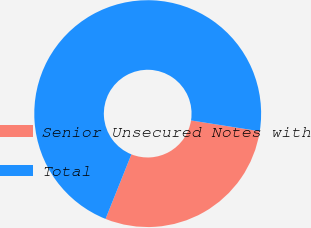<chart> <loc_0><loc_0><loc_500><loc_500><pie_chart><fcel>Senior Unsecured Notes with<fcel>Total<nl><fcel>28.58%<fcel>71.42%<nl></chart> 